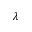Convert formula to latex. <formula><loc_0><loc_0><loc_500><loc_500>\lambda</formula> 